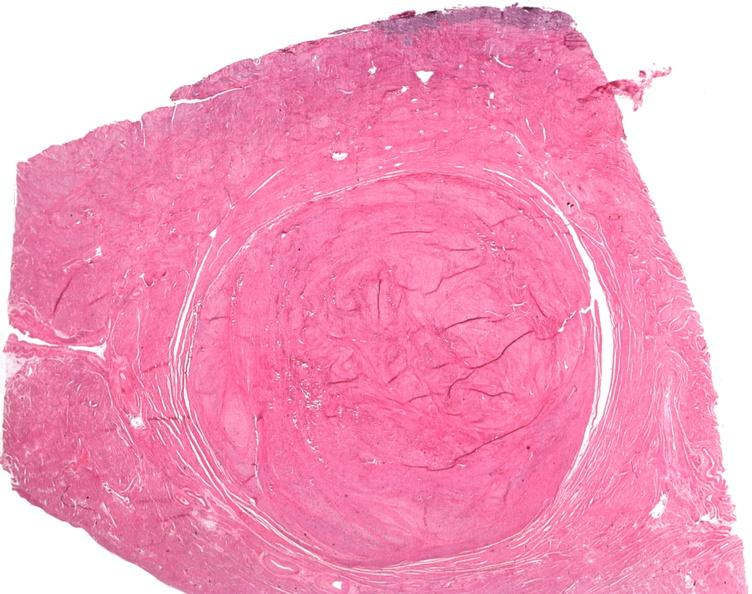s endometrial polyp present?
Answer the question using a single word or phrase. No 